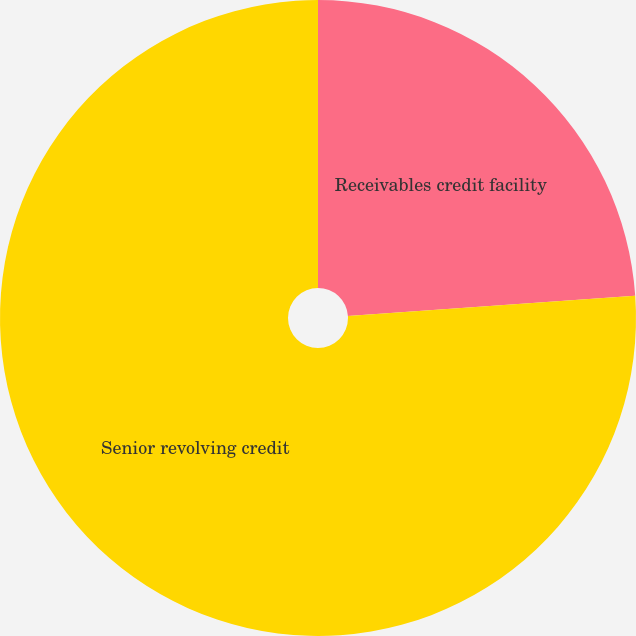Convert chart. <chart><loc_0><loc_0><loc_500><loc_500><pie_chart><fcel>Receivables credit facility<fcel>Senior revolving credit<nl><fcel>23.89%<fcel>76.11%<nl></chart> 